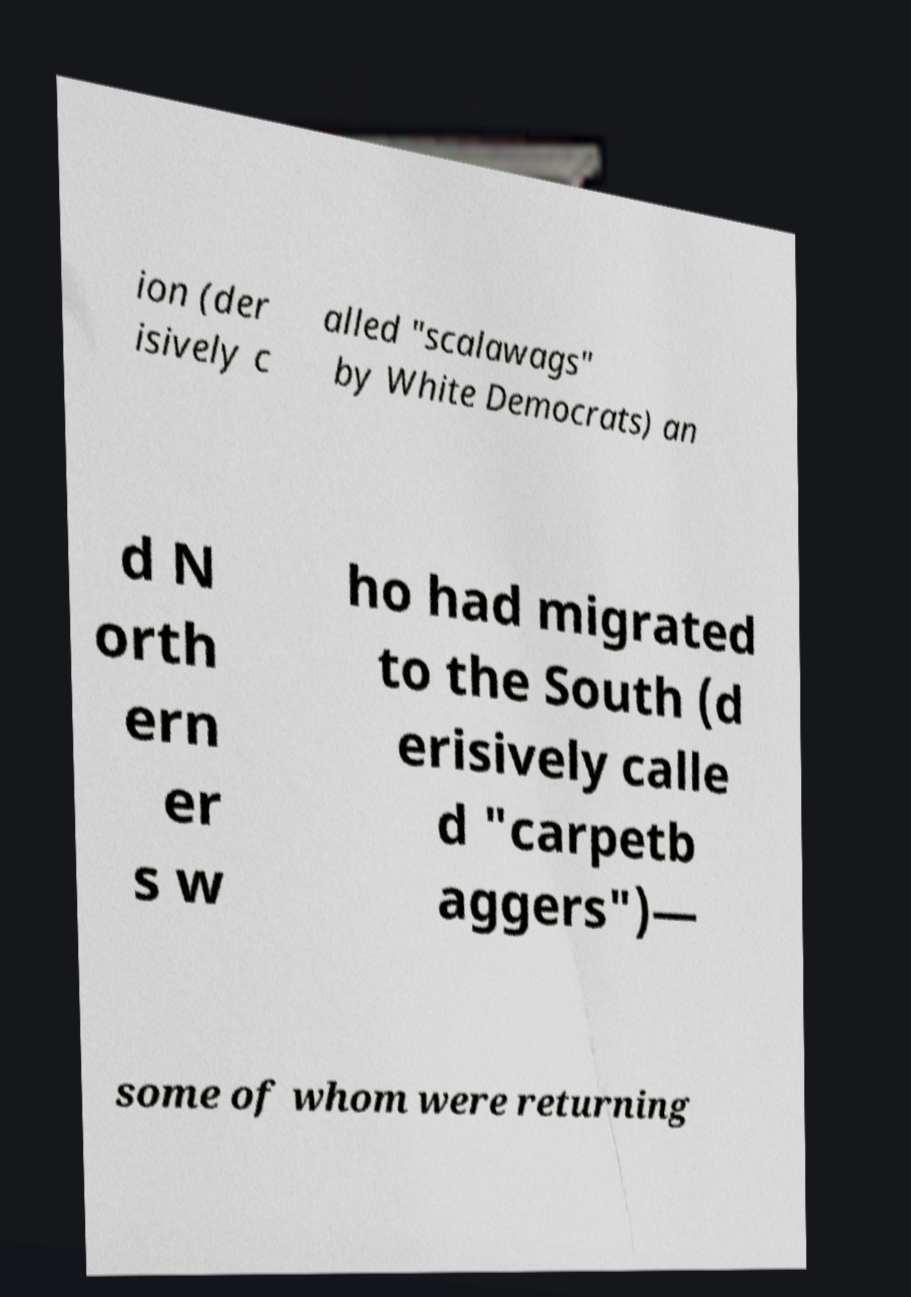Please identify and transcribe the text found in this image. ion (der isively c alled "scalawags" by White Democrats) an d N orth ern er s w ho had migrated to the South (d erisively calle d "carpetb aggers")— some of whom were returning 